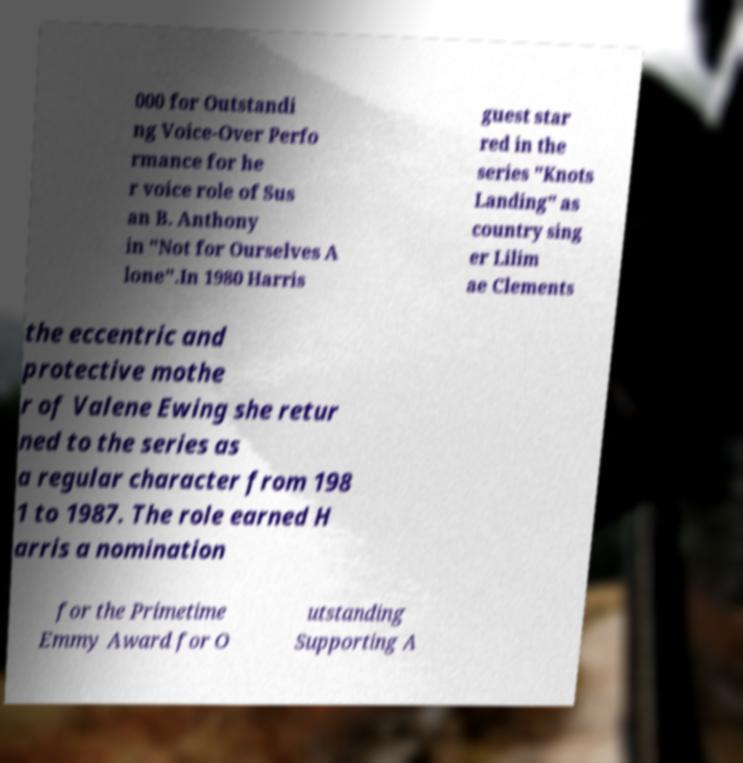Please identify and transcribe the text found in this image. 000 for Outstandi ng Voice-Over Perfo rmance for he r voice role of Sus an B. Anthony in "Not for Ourselves A lone".In 1980 Harris guest star red in the series "Knots Landing" as country sing er Lilim ae Clements the eccentric and protective mothe r of Valene Ewing she retur ned to the series as a regular character from 198 1 to 1987. The role earned H arris a nomination for the Primetime Emmy Award for O utstanding Supporting A 